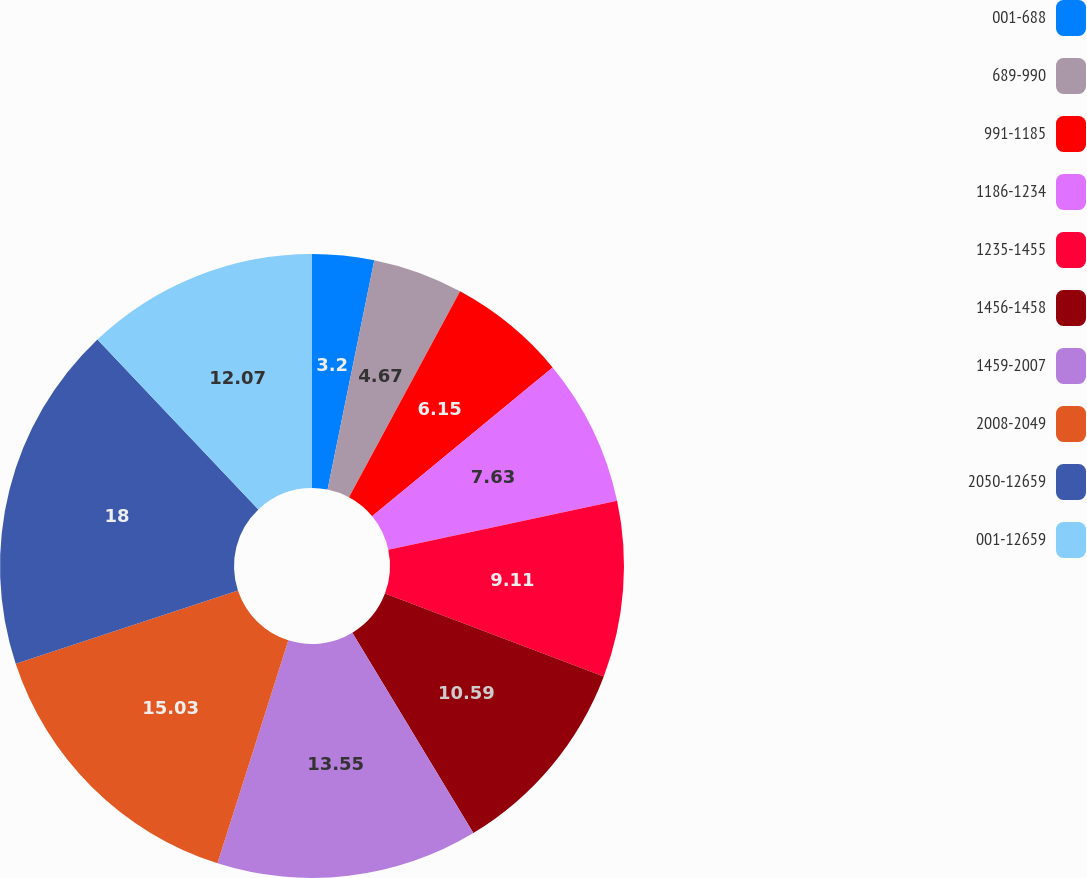Convert chart to OTSL. <chart><loc_0><loc_0><loc_500><loc_500><pie_chart><fcel>001-688<fcel>689-990<fcel>991-1185<fcel>1186-1234<fcel>1235-1455<fcel>1456-1458<fcel>1459-2007<fcel>2008-2049<fcel>2050-12659<fcel>001-12659<nl><fcel>3.2%<fcel>4.67%<fcel>6.15%<fcel>7.63%<fcel>9.11%<fcel>10.59%<fcel>13.55%<fcel>15.03%<fcel>18.0%<fcel>12.07%<nl></chart> 